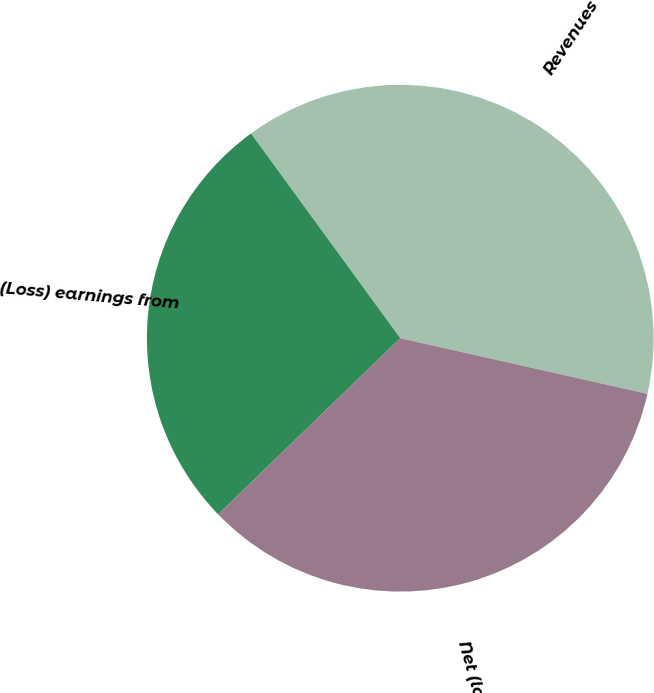<chart> <loc_0><loc_0><loc_500><loc_500><pie_chart><fcel>Revenues<fcel>(Loss) earnings from<fcel>Net (loss) earnings<nl><fcel>38.55%<fcel>27.21%<fcel>34.24%<nl></chart> 